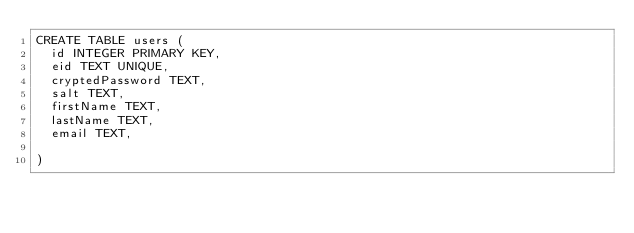Convert code to text. <code><loc_0><loc_0><loc_500><loc_500><_SQL_>CREATE TABLE users (
	id INTEGER PRIMARY KEY,
	eid TEXT UNIQUE,
	cryptedPassword TEXT,
	salt TEXT,
	firstName TEXT,
	lastName TEXT,
	email TEXT,
	
)
</code> 